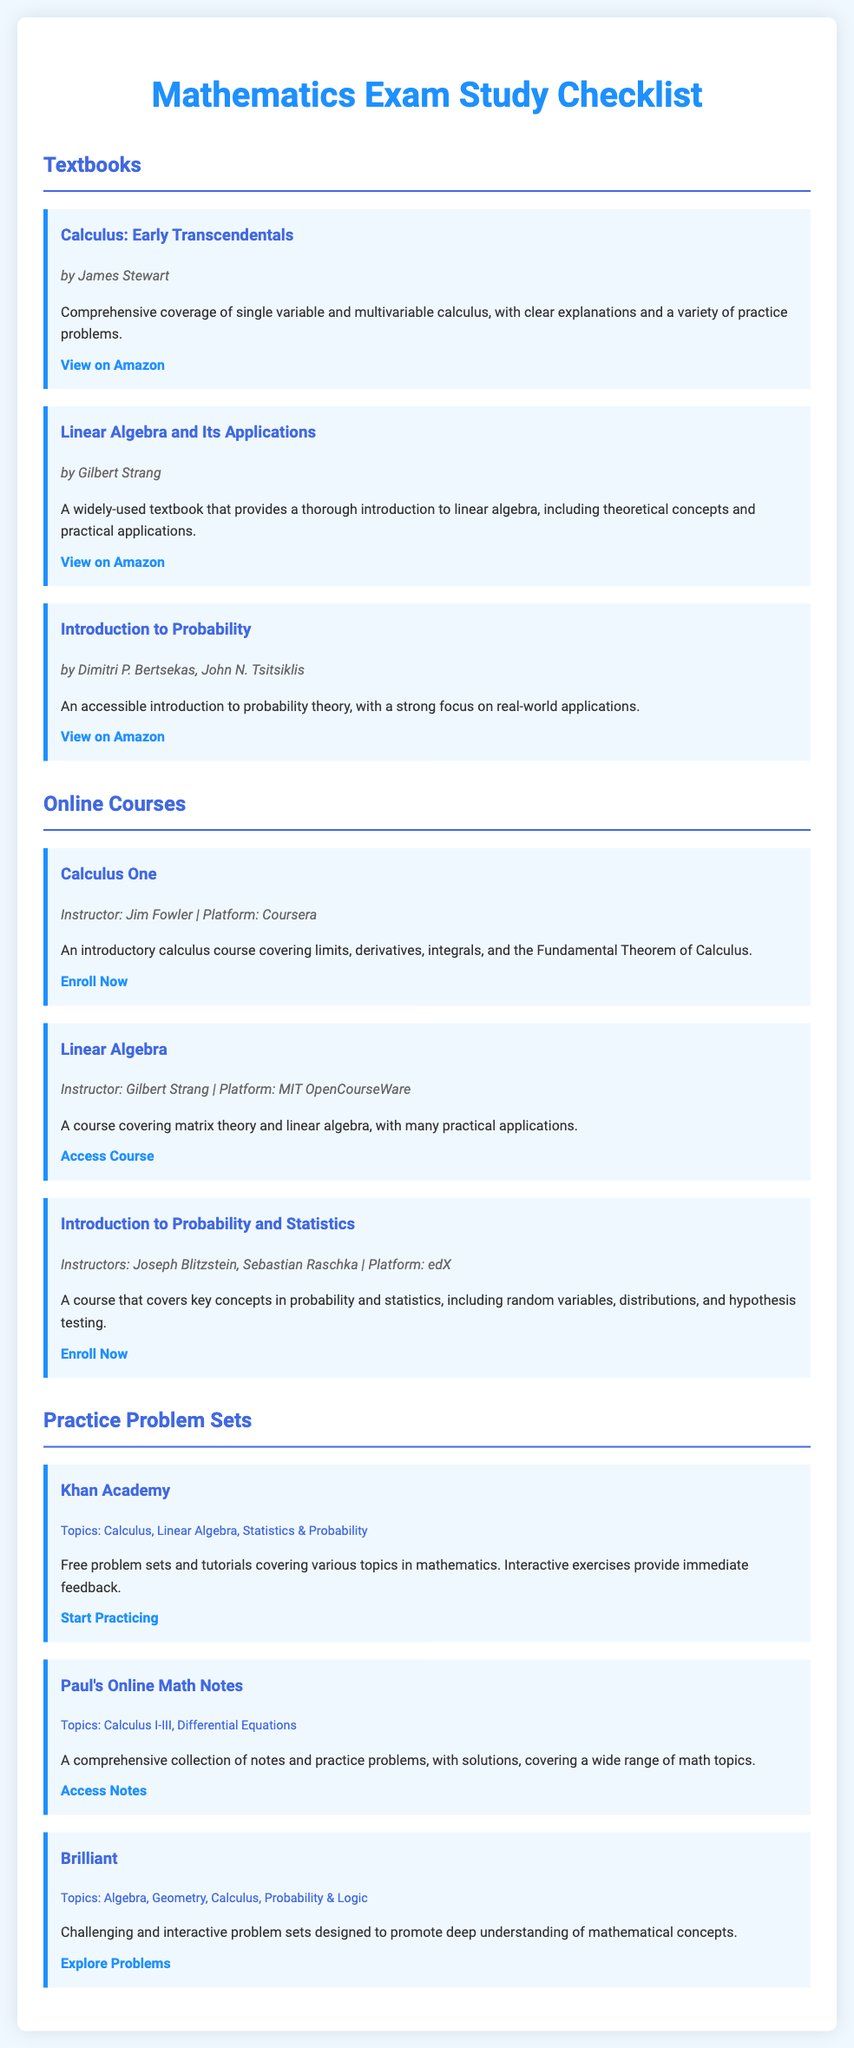what is the title of the document? The title of the document is presented prominently at the top of the page in a large font.
Answer: Mathematics Exam Study Checklist who is the author of "Calculus: Early Transcendentals"? The author's name is listed below the title of the textbook.
Answer: James Stewart how many online courses are listed in the document? The document presents three online courses under a specific heading.
Answer: 3 which textbook is authored by Gilbert Strang? The document specifies the textbooks and their respective authors.
Answer: Linear Algebra and Its Applications what topics are covered by Khan Academy? The topics covered by Khan Academy are mentioned in the resources section.
Answer: Calculus, Linear Algebra, Statistics & Probability which platform offers the course "Introduction to Probability and Statistics"? The platform for each course is explicitly stated in the course descriptions.
Answer: edX how many practice problem sets are included in the document? The document categorizes the resources into three sections including practice problem sets.
Answer: 3 what is the focus of the course "Calculus One"? The document provides descriptions for each online course, highlighting what they cover.
Answer: Limits, derivatives, integrals, and the Fundamental Theorem of Calculus 